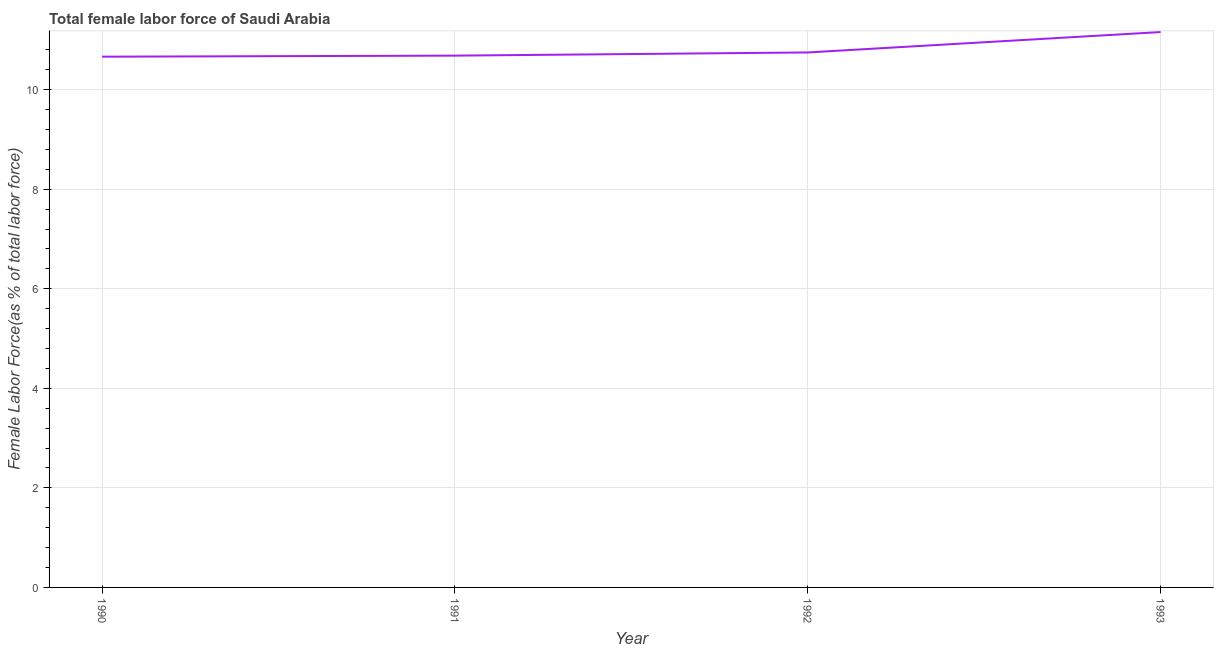What is the total female labor force in 1991?
Offer a terse response. 10.68. Across all years, what is the maximum total female labor force?
Give a very brief answer. 11.16. Across all years, what is the minimum total female labor force?
Offer a terse response. 10.66. In which year was the total female labor force maximum?
Your answer should be compact. 1993. What is the sum of the total female labor force?
Your answer should be very brief. 43.25. What is the difference between the total female labor force in 1990 and 1991?
Offer a terse response. -0.02. What is the average total female labor force per year?
Ensure brevity in your answer.  10.81. What is the median total female labor force?
Provide a succinct answer. 10.71. What is the ratio of the total female labor force in 1990 to that in 1991?
Keep it short and to the point. 1. Is the difference between the total female labor force in 1990 and 1991 greater than the difference between any two years?
Your response must be concise. No. What is the difference between the highest and the second highest total female labor force?
Keep it short and to the point. 0.41. Is the sum of the total female labor force in 1990 and 1992 greater than the maximum total female labor force across all years?
Your answer should be very brief. Yes. What is the difference between the highest and the lowest total female labor force?
Keep it short and to the point. 0.49. Does the total female labor force monotonically increase over the years?
Provide a succinct answer. Yes. How many lines are there?
Give a very brief answer. 1. What is the difference between two consecutive major ticks on the Y-axis?
Give a very brief answer. 2. Does the graph contain any zero values?
Your answer should be compact. No. What is the title of the graph?
Provide a succinct answer. Total female labor force of Saudi Arabia. What is the label or title of the X-axis?
Provide a succinct answer. Year. What is the label or title of the Y-axis?
Ensure brevity in your answer.  Female Labor Force(as % of total labor force). What is the Female Labor Force(as % of total labor force) of 1990?
Provide a short and direct response. 10.66. What is the Female Labor Force(as % of total labor force) of 1991?
Your answer should be very brief. 10.68. What is the Female Labor Force(as % of total labor force) of 1992?
Your answer should be very brief. 10.75. What is the Female Labor Force(as % of total labor force) in 1993?
Your answer should be compact. 11.16. What is the difference between the Female Labor Force(as % of total labor force) in 1990 and 1991?
Ensure brevity in your answer.  -0.02. What is the difference between the Female Labor Force(as % of total labor force) in 1990 and 1992?
Keep it short and to the point. -0.08. What is the difference between the Female Labor Force(as % of total labor force) in 1990 and 1993?
Offer a very short reply. -0.49. What is the difference between the Female Labor Force(as % of total labor force) in 1991 and 1992?
Your response must be concise. -0.06. What is the difference between the Female Labor Force(as % of total labor force) in 1991 and 1993?
Give a very brief answer. -0.47. What is the difference between the Female Labor Force(as % of total labor force) in 1992 and 1993?
Offer a very short reply. -0.41. What is the ratio of the Female Labor Force(as % of total labor force) in 1990 to that in 1993?
Ensure brevity in your answer.  0.96. What is the ratio of the Female Labor Force(as % of total labor force) in 1991 to that in 1993?
Your response must be concise. 0.96. 